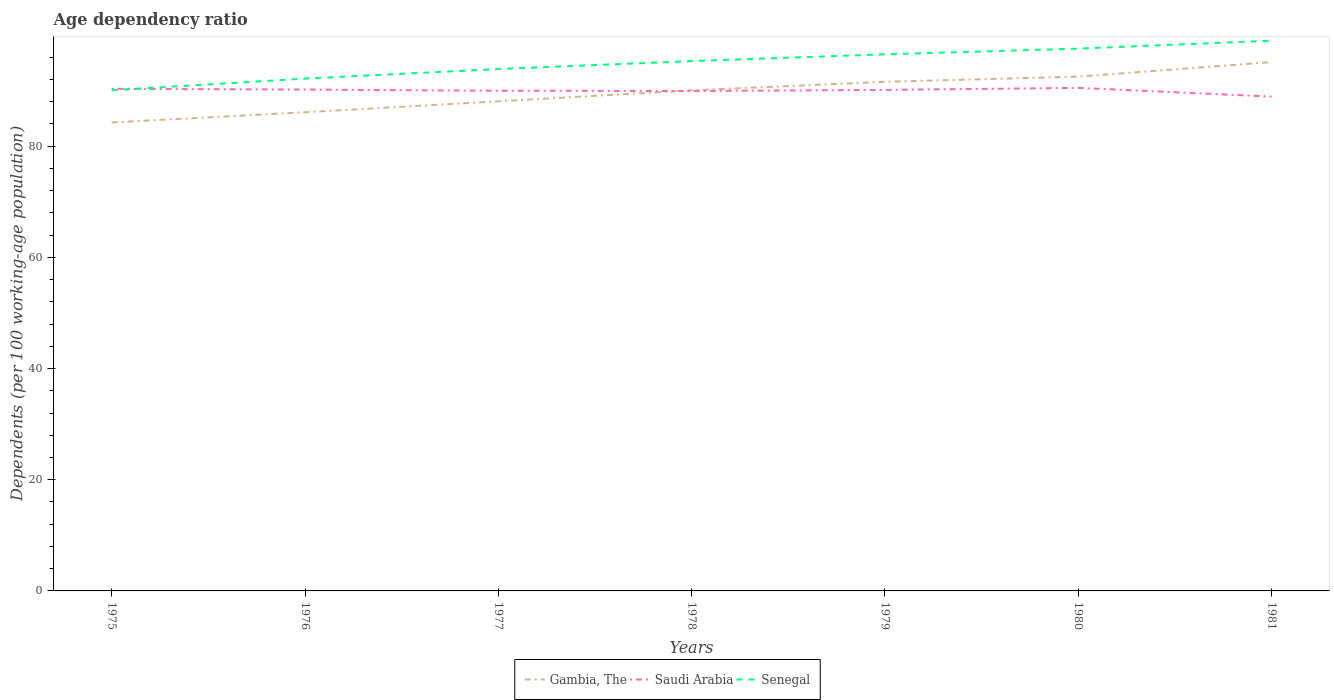Does the line corresponding to Gambia, The intersect with the line corresponding to Senegal?
Make the answer very short. No. Is the number of lines equal to the number of legend labels?
Your response must be concise. Yes. Across all years, what is the maximum age dependency ratio in in Gambia, The?
Ensure brevity in your answer.  84.27. What is the total age dependency ratio in in Saudi Arabia in the graph?
Give a very brief answer. -0.36. What is the difference between the highest and the second highest age dependency ratio in in Senegal?
Provide a short and direct response. 8.92. What is the difference between the highest and the lowest age dependency ratio in in Senegal?
Your answer should be compact. 4. Is the age dependency ratio in in Gambia, The strictly greater than the age dependency ratio in in Saudi Arabia over the years?
Give a very brief answer. No. How many lines are there?
Provide a succinct answer. 3. Are the values on the major ticks of Y-axis written in scientific E-notation?
Ensure brevity in your answer.  No. Does the graph contain any zero values?
Offer a very short reply. No. Where does the legend appear in the graph?
Give a very brief answer. Bottom center. How are the legend labels stacked?
Provide a short and direct response. Horizontal. What is the title of the graph?
Provide a short and direct response. Age dependency ratio. What is the label or title of the X-axis?
Ensure brevity in your answer.  Years. What is the label or title of the Y-axis?
Your answer should be compact. Dependents (per 100 working-age population). What is the Dependents (per 100 working-age population) of Gambia, The in 1975?
Your response must be concise. 84.27. What is the Dependents (per 100 working-age population) of Saudi Arabia in 1975?
Offer a terse response. 90.32. What is the Dependents (per 100 working-age population) of Senegal in 1975?
Make the answer very short. 90.06. What is the Dependents (per 100 working-age population) of Gambia, The in 1976?
Offer a very short reply. 86.1. What is the Dependents (per 100 working-age population) of Saudi Arabia in 1976?
Provide a succinct answer. 90.18. What is the Dependents (per 100 working-age population) of Senegal in 1976?
Provide a succinct answer. 92.16. What is the Dependents (per 100 working-age population) of Gambia, The in 1977?
Provide a short and direct response. 88.07. What is the Dependents (per 100 working-age population) in Saudi Arabia in 1977?
Keep it short and to the point. 89.97. What is the Dependents (per 100 working-age population) in Senegal in 1977?
Provide a succinct answer. 93.88. What is the Dependents (per 100 working-age population) in Gambia, The in 1978?
Provide a short and direct response. 90.04. What is the Dependents (per 100 working-age population) of Saudi Arabia in 1978?
Your response must be concise. 89.92. What is the Dependents (per 100 working-age population) of Senegal in 1978?
Your response must be concise. 95.3. What is the Dependents (per 100 working-age population) in Gambia, The in 1979?
Provide a short and direct response. 91.58. What is the Dependents (per 100 working-age population) in Saudi Arabia in 1979?
Your response must be concise. 90.13. What is the Dependents (per 100 working-age population) of Senegal in 1979?
Keep it short and to the point. 96.52. What is the Dependents (per 100 working-age population) in Gambia, The in 1980?
Keep it short and to the point. 92.51. What is the Dependents (per 100 working-age population) in Saudi Arabia in 1980?
Offer a terse response. 90.49. What is the Dependents (per 100 working-age population) of Senegal in 1980?
Make the answer very short. 97.55. What is the Dependents (per 100 working-age population) in Gambia, The in 1981?
Provide a succinct answer. 95.13. What is the Dependents (per 100 working-age population) of Saudi Arabia in 1981?
Make the answer very short. 88.92. What is the Dependents (per 100 working-age population) of Senegal in 1981?
Ensure brevity in your answer.  98.98. Across all years, what is the maximum Dependents (per 100 working-age population) of Gambia, The?
Make the answer very short. 95.13. Across all years, what is the maximum Dependents (per 100 working-age population) of Saudi Arabia?
Your answer should be very brief. 90.49. Across all years, what is the maximum Dependents (per 100 working-age population) of Senegal?
Offer a very short reply. 98.98. Across all years, what is the minimum Dependents (per 100 working-age population) of Gambia, The?
Provide a short and direct response. 84.27. Across all years, what is the minimum Dependents (per 100 working-age population) of Saudi Arabia?
Your answer should be very brief. 88.92. Across all years, what is the minimum Dependents (per 100 working-age population) in Senegal?
Keep it short and to the point. 90.06. What is the total Dependents (per 100 working-age population) of Gambia, The in the graph?
Give a very brief answer. 627.7. What is the total Dependents (per 100 working-age population) of Saudi Arabia in the graph?
Make the answer very short. 629.92. What is the total Dependents (per 100 working-age population) of Senegal in the graph?
Ensure brevity in your answer.  664.46. What is the difference between the Dependents (per 100 working-age population) in Gambia, The in 1975 and that in 1976?
Keep it short and to the point. -1.83. What is the difference between the Dependents (per 100 working-age population) in Saudi Arabia in 1975 and that in 1976?
Make the answer very short. 0.14. What is the difference between the Dependents (per 100 working-age population) of Senegal in 1975 and that in 1976?
Offer a terse response. -2.1. What is the difference between the Dependents (per 100 working-age population) of Gambia, The in 1975 and that in 1977?
Make the answer very short. -3.8. What is the difference between the Dependents (per 100 working-age population) in Saudi Arabia in 1975 and that in 1977?
Offer a terse response. 0.35. What is the difference between the Dependents (per 100 working-age population) in Senegal in 1975 and that in 1977?
Offer a terse response. -3.81. What is the difference between the Dependents (per 100 working-age population) in Gambia, The in 1975 and that in 1978?
Keep it short and to the point. -5.77. What is the difference between the Dependents (per 100 working-age population) in Saudi Arabia in 1975 and that in 1978?
Provide a short and direct response. 0.4. What is the difference between the Dependents (per 100 working-age population) in Senegal in 1975 and that in 1978?
Provide a short and direct response. -5.24. What is the difference between the Dependents (per 100 working-age population) of Gambia, The in 1975 and that in 1979?
Your answer should be very brief. -7.3. What is the difference between the Dependents (per 100 working-age population) in Saudi Arabia in 1975 and that in 1979?
Keep it short and to the point. 0.19. What is the difference between the Dependents (per 100 working-age population) in Senegal in 1975 and that in 1979?
Offer a terse response. -6.46. What is the difference between the Dependents (per 100 working-age population) of Gambia, The in 1975 and that in 1980?
Ensure brevity in your answer.  -8.23. What is the difference between the Dependents (per 100 working-age population) in Saudi Arabia in 1975 and that in 1980?
Give a very brief answer. -0.17. What is the difference between the Dependents (per 100 working-age population) of Senegal in 1975 and that in 1980?
Your answer should be very brief. -7.49. What is the difference between the Dependents (per 100 working-age population) in Gambia, The in 1975 and that in 1981?
Keep it short and to the point. -10.85. What is the difference between the Dependents (per 100 working-age population) in Saudi Arabia in 1975 and that in 1981?
Give a very brief answer. 1.4. What is the difference between the Dependents (per 100 working-age population) in Senegal in 1975 and that in 1981?
Your answer should be compact. -8.92. What is the difference between the Dependents (per 100 working-age population) in Gambia, The in 1976 and that in 1977?
Make the answer very short. -1.97. What is the difference between the Dependents (per 100 working-age population) of Saudi Arabia in 1976 and that in 1977?
Your answer should be very brief. 0.21. What is the difference between the Dependents (per 100 working-age population) of Senegal in 1976 and that in 1977?
Your answer should be very brief. -1.72. What is the difference between the Dependents (per 100 working-age population) in Gambia, The in 1976 and that in 1978?
Keep it short and to the point. -3.94. What is the difference between the Dependents (per 100 working-age population) in Saudi Arabia in 1976 and that in 1978?
Make the answer very short. 0.26. What is the difference between the Dependents (per 100 working-age population) of Senegal in 1976 and that in 1978?
Offer a very short reply. -3.15. What is the difference between the Dependents (per 100 working-age population) of Gambia, The in 1976 and that in 1979?
Keep it short and to the point. -5.48. What is the difference between the Dependents (per 100 working-age population) of Saudi Arabia in 1976 and that in 1979?
Your answer should be compact. 0.06. What is the difference between the Dependents (per 100 working-age population) of Senegal in 1976 and that in 1979?
Provide a short and direct response. -4.36. What is the difference between the Dependents (per 100 working-age population) in Gambia, The in 1976 and that in 1980?
Offer a terse response. -6.41. What is the difference between the Dependents (per 100 working-age population) in Saudi Arabia in 1976 and that in 1980?
Offer a terse response. -0.31. What is the difference between the Dependents (per 100 working-age population) of Senegal in 1976 and that in 1980?
Offer a very short reply. -5.39. What is the difference between the Dependents (per 100 working-age population) of Gambia, The in 1976 and that in 1981?
Your answer should be compact. -9.03. What is the difference between the Dependents (per 100 working-age population) of Saudi Arabia in 1976 and that in 1981?
Your answer should be very brief. 1.26. What is the difference between the Dependents (per 100 working-age population) of Senegal in 1976 and that in 1981?
Keep it short and to the point. -6.82. What is the difference between the Dependents (per 100 working-age population) in Gambia, The in 1977 and that in 1978?
Make the answer very short. -1.97. What is the difference between the Dependents (per 100 working-age population) in Saudi Arabia in 1977 and that in 1978?
Ensure brevity in your answer.  0.05. What is the difference between the Dependents (per 100 working-age population) of Senegal in 1977 and that in 1978?
Ensure brevity in your answer.  -1.43. What is the difference between the Dependents (per 100 working-age population) of Gambia, The in 1977 and that in 1979?
Provide a succinct answer. -3.51. What is the difference between the Dependents (per 100 working-age population) in Saudi Arabia in 1977 and that in 1979?
Ensure brevity in your answer.  -0.15. What is the difference between the Dependents (per 100 working-age population) of Senegal in 1977 and that in 1979?
Offer a very short reply. -2.65. What is the difference between the Dependents (per 100 working-age population) of Gambia, The in 1977 and that in 1980?
Ensure brevity in your answer.  -4.43. What is the difference between the Dependents (per 100 working-age population) in Saudi Arabia in 1977 and that in 1980?
Give a very brief answer. -0.51. What is the difference between the Dependents (per 100 working-age population) of Senegal in 1977 and that in 1980?
Offer a very short reply. -3.67. What is the difference between the Dependents (per 100 working-age population) in Gambia, The in 1977 and that in 1981?
Ensure brevity in your answer.  -7.05. What is the difference between the Dependents (per 100 working-age population) of Saudi Arabia in 1977 and that in 1981?
Your answer should be compact. 1.05. What is the difference between the Dependents (per 100 working-age population) of Senegal in 1977 and that in 1981?
Make the answer very short. -5.1. What is the difference between the Dependents (per 100 working-age population) in Gambia, The in 1978 and that in 1979?
Make the answer very short. -1.54. What is the difference between the Dependents (per 100 working-age population) in Saudi Arabia in 1978 and that in 1979?
Offer a very short reply. -0.21. What is the difference between the Dependents (per 100 working-age population) of Senegal in 1978 and that in 1979?
Your answer should be very brief. -1.22. What is the difference between the Dependents (per 100 working-age population) in Gambia, The in 1978 and that in 1980?
Keep it short and to the point. -2.47. What is the difference between the Dependents (per 100 working-age population) of Saudi Arabia in 1978 and that in 1980?
Keep it short and to the point. -0.57. What is the difference between the Dependents (per 100 working-age population) in Senegal in 1978 and that in 1980?
Make the answer very short. -2.25. What is the difference between the Dependents (per 100 working-age population) of Gambia, The in 1978 and that in 1981?
Offer a terse response. -5.09. What is the difference between the Dependents (per 100 working-age population) in Saudi Arabia in 1978 and that in 1981?
Your answer should be compact. 1. What is the difference between the Dependents (per 100 working-age population) in Senegal in 1978 and that in 1981?
Offer a very short reply. -3.67. What is the difference between the Dependents (per 100 working-age population) in Gambia, The in 1979 and that in 1980?
Your answer should be very brief. -0.93. What is the difference between the Dependents (per 100 working-age population) in Saudi Arabia in 1979 and that in 1980?
Provide a succinct answer. -0.36. What is the difference between the Dependents (per 100 working-age population) of Senegal in 1979 and that in 1980?
Your answer should be very brief. -1.03. What is the difference between the Dependents (per 100 working-age population) of Gambia, The in 1979 and that in 1981?
Make the answer very short. -3.55. What is the difference between the Dependents (per 100 working-age population) in Saudi Arabia in 1979 and that in 1981?
Offer a very short reply. 1.21. What is the difference between the Dependents (per 100 working-age population) in Senegal in 1979 and that in 1981?
Provide a short and direct response. -2.46. What is the difference between the Dependents (per 100 working-age population) of Gambia, The in 1980 and that in 1981?
Your response must be concise. -2.62. What is the difference between the Dependents (per 100 working-age population) in Saudi Arabia in 1980 and that in 1981?
Offer a terse response. 1.57. What is the difference between the Dependents (per 100 working-age population) of Senegal in 1980 and that in 1981?
Offer a very short reply. -1.43. What is the difference between the Dependents (per 100 working-age population) of Gambia, The in 1975 and the Dependents (per 100 working-age population) of Saudi Arabia in 1976?
Offer a very short reply. -5.91. What is the difference between the Dependents (per 100 working-age population) in Gambia, The in 1975 and the Dependents (per 100 working-age population) in Senegal in 1976?
Give a very brief answer. -7.88. What is the difference between the Dependents (per 100 working-age population) of Saudi Arabia in 1975 and the Dependents (per 100 working-age population) of Senegal in 1976?
Provide a short and direct response. -1.84. What is the difference between the Dependents (per 100 working-age population) of Gambia, The in 1975 and the Dependents (per 100 working-age population) of Saudi Arabia in 1977?
Your response must be concise. -5.7. What is the difference between the Dependents (per 100 working-age population) in Gambia, The in 1975 and the Dependents (per 100 working-age population) in Senegal in 1977?
Offer a terse response. -9.6. What is the difference between the Dependents (per 100 working-age population) of Saudi Arabia in 1975 and the Dependents (per 100 working-age population) of Senegal in 1977?
Your answer should be compact. -3.56. What is the difference between the Dependents (per 100 working-age population) in Gambia, The in 1975 and the Dependents (per 100 working-age population) in Saudi Arabia in 1978?
Provide a short and direct response. -5.64. What is the difference between the Dependents (per 100 working-age population) in Gambia, The in 1975 and the Dependents (per 100 working-age population) in Senegal in 1978?
Provide a succinct answer. -11.03. What is the difference between the Dependents (per 100 working-age population) of Saudi Arabia in 1975 and the Dependents (per 100 working-age population) of Senegal in 1978?
Make the answer very short. -4.99. What is the difference between the Dependents (per 100 working-age population) in Gambia, The in 1975 and the Dependents (per 100 working-age population) in Saudi Arabia in 1979?
Give a very brief answer. -5.85. What is the difference between the Dependents (per 100 working-age population) in Gambia, The in 1975 and the Dependents (per 100 working-age population) in Senegal in 1979?
Give a very brief answer. -12.25. What is the difference between the Dependents (per 100 working-age population) in Saudi Arabia in 1975 and the Dependents (per 100 working-age population) in Senegal in 1979?
Your answer should be very brief. -6.21. What is the difference between the Dependents (per 100 working-age population) of Gambia, The in 1975 and the Dependents (per 100 working-age population) of Saudi Arabia in 1980?
Give a very brief answer. -6.21. What is the difference between the Dependents (per 100 working-age population) of Gambia, The in 1975 and the Dependents (per 100 working-age population) of Senegal in 1980?
Make the answer very short. -13.28. What is the difference between the Dependents (per 100 working-age population) of Saudi Arabia in 1975 and the Dependents (per 100 working-age population) of Senegal in 1980?
Make the answer very short. -7.23. What is the difference between the Dependents (per 100 working-age population) of Gambia, The in 1975 and the Dependents (per 100 working-age population) of Saudi Arabia in 1981?
Ensure brevity in your answer.  -4.64. What is the difference between the Dependents (per 100 working-age population) in Gambia, The in 1975 and the Dependents (per 100 working-age population) in Senegal in 1981?
Offer a very short reply. -14.71. What is the difference between the Dependents (per 100 working-age population) of Saudi Arabia in 1975 and the Dependents (per 100 working-age population) of Senegal in 1981?
Your answer should be compact. -8.66. What is the difference between the Dependents (per 100 working-age population) in Gambia, The in 1976 and the Dependents (per 100 working-age population) in Saudi Arabia in 1977?
Provide a short and direct response. -3.87. What is the difference between the Dependents (per 100 working-age population) of Gambia, The in 1976 and the Dependents (per 100 working-age population) of Senegal in 1977?
Make the answer very short. -7.78. What is the difference between the Dependents (per 100 working-age population) in Saudi Arabia in 1976 and the Dependents (per 100 working-age population) in Senegal in 1977?
Offer a terse response. -3.7. What is the difference between the Dependents (per 100 working-age population) of Gambia, The in 1976 and the Dependents (per 100 working-age population) of Saudi Arabia in 1978?
Make the answer very short. -3.82. What is the difference between the Dependents (per 100 working-age population) in Gambia, The in 1976 and the Dependents (per 100 working-age population) in Senegal in 1978?
Your answer should be compact. -9.21. What is the difference between the Dependents (per 100 working-age population) in Saudi Arabia in 1976 and the Dependents (per 100 working-age population) in Senegal in 1978?
Your response must be concise. -5.12. What is the difference between the Dependents (per 100 working-age population) of Gambia, The in 1976 and the Dependents (per 100 working-age population) of Saudi Arabia in 1979?
Give a very brief answer. -4.03. What is the difference between the Dependents (per 100 working-age population) in Gambia, The in 1976 and the Dependents (per 100 working-age population) in Senegal in 1979?
Ensure brevity in your answer.  -10.42. What is the difference between the Dependents (per 100 working-age population) of Saudi Arabia in 1976 and the Dependents (per 100 working-age population) of Senegal in 1979?
Provide a succinct answer. -6.34. What is the difference between the Dependents (per 100 working-age population) in Gambia, The in 1976 and the Dependents (per 100 working-age population) in Saudi Arabia in 1980?
Your response must be concise. -4.39. What is the difference between the Dependents (per 100 working-age population) in Gambia, The in 1976 and the Dependents (per 100 working-age population) in Senegal in 1980?
Offer a very short reply. -11.45. What is the difference between the Dependents (per 100 working-age population) of Saudi Arabia in 1976 and the Dependents (per 100 working-age population) of Senegal in 1980?
Give a very brief answer. -7.37. What is the difference between the Dependents (per 100 working-age population) of Gambia, The in 1976 and the Dependents (per 100 working-age population) of Saudi Arabia in 1981?
Keep it short and to the point. -2.82. What is the difference between the Dependents (per 100 working-age population) of Gambia, The in 1976 and the Dependents (per 100 working-age population) of Senegal in 1981?
Ensure brevity in your answer.  -12.88. What is the difference between the Dependents (per 100 working-age population) of Saudi Arabia in 1976 and the Dependents (per 100 working-age population) of Senegal in 1981?
Give a very brief answer. -8.8. What is the difference between the Dependents (per 100 working-age population) in Gambia, The in 1977 and the Dependents (per 100 working-age population) in Saudi Arabia in 1978?
Your response must be concise. -1.85. What is the difference between the Dependents (per 100 working-age population) in Gambia, The in 1977 and the Dependents (per 100 working-age population) in Senegal in 1978?
Your answer should be very brief. -7.23. What is the difference between the Dependents (per 100 working-age population) of Saudi Arabia in 1977 and the Dependents (per 100 working-age population) of Senegal in 1978?
Provide a succinct answer. -5.33. What is the difference between the Dependents (per 100 working-age population) in Gambia, The in 1977 and the Dependents (per 100 working-age population) in Saudi Arabia in 1979?
Your response must be concise. -2.05. What is the difference between the Dependents (per 100 working-age population) of Gambia, The in 1977 and the Dependents (per 100 working-age population) of Senegal in 1979?
Provide a short and direct response. -8.45. What is the difference between the Dependents (per 100 working-age population) in Saudi Arabia in 1977 and the Dependents (per 100 working-age population) in Senegal in 1979?
Make the answer very short. -6.55. What is the difference between the Dependents (per 100 working-age population) in Gambia, The in 1977 and the Dependents (per 100 working-age population) in Saudi Arabia in 1980?
Provide a succinct answer. -2.41. What is the difference between the Dependents (per 100 working-age population) in Gambia, The in 1977 and the Dependents (per 100 working-age population) in Senegal in 1980?
Ensure brevity in your answer.  -9.48. What is the difference between the Dependents (per 100 working-age population) of Saudi Arabia in 1977 and the Dependents (per 100 working-age population) of Senegal in 1980?
Ensure brevity in your answer.  -7.58. What is the difference between the Dependents (per 100 working-age population) in Gambia, The in 1977 and the Dependents (per 100 working-age population) in Saudi Arabia in 1981?
Make the answer very short. -0.84. What is the difference between the Dependents (per 100 working-age population) of Gambia, The in 1977 and the Dependents (per 100 working-age population) of Senegal in 1981?
Your answer should be very brief. -10.91. What is the difference between the Dependents (per 100 working-age population) of Saudi Arabia in 1977 and the Dependents (per 100 working-age population) of Senegal in 1981?
Offer a terse response. -9.01. What is the difference between the Dependents (per 100 working-age population) in Gambia, The in 1978 and the Dependents (per 100 working-age population) in Saudi Arabia in 1979?
Provide a succinct answer. -0.08. What is the difference between the Dependents (per 100 working-age population) in Gambia, The in 1978 and the Dependents (per 100 working-age population) in Senegal in 1979?
Make the answer very short. -6.48. What is the difference between the Dependents (per 100 working-age population) of Saudi Arabia in 1978 and the Dependents (per 100 working-age population) of Senegal in 1979?
Keep it short and to the point. -6.6. What is the difference between the Dependents (per 100 working-age population) in Gambia, The in 1978 and the Dependents (per 100 working-age population) in Saudi Arabia in 1980?
Offer a very short reply. -0.45. What is the difference between the Dependents (per 100 working-age population) of Gambia, The in 1978 and the Dependents (per 100 working-age population) of Senegal in 1980?
Your answer should be very brief. -7.51. What is the difference between the Dependents (per 100 working-age population) in Saudi Arabia in 1978 and the Dependents (per 100 working-age population) in Senegal in 1980?
Keep it short and to the point. -7.63. What is the difference between the Dependents (per 100 working-age population) of Gambia, The in 1978 and the Dependents (per 100 working-age population) of Saudi Arabia in 1981?
Your response must be concise. 1.12. What is the difference between the Dependents (per 100 working-age population) of Gambia, The in 1978 and the Dependents (per 100 working-age population) of Senegal in 1981?
Your answer should be compact. -8.94. What is the difference between the Dependents (per 100 working-age population) of Saudi Arabia in 1978 and the Dependents (per 100 working-age population) of Senegal in 1981?
Offer a terse response. -9.06. What is the difference between the Dependents (per 100 working-age population) in Gambia, The in 1979 and the Dependents (per 100 working-age population) in Saudi Arabia in 1980?
Keep it short and to the point. 1.09. What is the difference between the Dependents (per 100 working-age population) of Gambia, The in 1979 and the Dependents (per 100 working-age population) of Senegal in 1980?
Your answer should be compact. -5.97. What is the difference between the Dependents (per 100 working-age population) of Saudi Arabia in 1979 and the Dependents (per 100 working-age population) of Senegal in 1980?
Make the answer very short. -7.42. What is the difference between the Dependents (per 100 working-age population) in Gambia, The in 1979 and the Dependents (per 100 working-age population) in Saudi Arabia in 1981?
Give a very brief answer. 2.66. What is the difference between the Dependents (per 100 working-age population) of Gambia, The in 1979 and the Dependents (per 100 working-age population) of Senegal in 1981?
Ensure brevity in your answer.  -7.4. What is the difference between the Dependents (per 100 working-age population) of Saudi Arabia in 1979 and the Dependents (per 100 working-age population) of Senegal in 1981?
Provide a succinct answer. -8.85. What is the difference between the Dependents (per 100 working-age population) of Gambia, The in 1980 and the Dependents (per 100 working-age population) of Saudi Arabia in 1981?
Your answer should be very brief. 3.59. What is the difference between the Dependents (per 100 working-age population) of Gambia, The in 1980 and the Dependents (per 100 working-age population) of Senegal in 1981?
Your response must be concise. -6.47. What is the difference between the Dependents (per 100 working-age population) of Saudi Arabia in 1980 and the Dependents (per 100 working-age population) of Senegal in 1981?
Ensure brevity in your answer.  -8.49. What is the average Dependents (per 100 working-age population) of Gambia, The per year?
Provide a succinct answer. 89.67. What is the average Dependents (per 100 working-age population) of Saudi Arabia per year?
Offer a very short reply. 89.99. What is the average Dependents (per 100 working-age population) of Senegal per year?
Give a very brief answer. 94.92. In the year 1975, what is the difference between the Dependents (per 100 working-age population) of Gambia, The and Dependents (per 100 working-age population) of Saudi Arabia?
Offer a terse response. -6.04. In the year 1975, what is the difference between the Dependents (per 100 working-age population) in Gambia, The and Dependents (per 100 working-age population) in Senegal?
Offer a very short reply. -5.79. In the year 1975, what is the difference between the Dependents (per 100 working-age population) of Saudi Arabia and Dependents (per 100 working-age population) of Senegal?
Provide a short and direct response. 0.25. In the year 1976, what is the difference between the Dependents (per 100 working-age population) in Gambia, The and Dependents (per 100 working-age population) in Saudi Arabia?
Provide a short and direct response. -4.08. In the year 1976, what is the difference between the Dependents (per 100 working-age population) in Gambia, The and Dependents (per 100 working-age population) in Senegal?
Make the answer very short. -6.06. In the year 1976, what is the difference between the Dependents (per 100 working-age population) in Saudi Arabia and Dependents (per 100 working-age population) in Senegal?
Your answer should be very brief. -1.98. In the year 1977, what is the difference between the Dependents (per 100 working-age population) of Gambia, The and Dependents (per 100 working-age population) of Saudi Arabia?
Provide a short and direct response. -1.9. In the year 1977, what is the difference between the Dependents (per 100 working-age population) of Gambia, The and Dependents (per 100 working-age population) of Senegal?
Provide a short and direct response. -5.8. In the year 1977, what is the difference between the Dependents (per 100 working-age population) in Saudi Arabia and Dependents (per 100 working-age population) in Senegal?
Give a very brief answer. -3.9. In the year 1978, what is the difference between the Dependents (per 100 working-age population) in Gambia, The and Dependents (per 100 working-age population) in Saudi Arabia?
Make the answer very short. 0.12. In the year 1978, what is the difference between the Dependents (per 100 working-age population) in Gambia, The and Dependents (per 100 working-age population) in Senegal?
Your answer should be very brief. -5.26. In the year 1978, what is the difference between the Dependents (per 100 working-age population) of Saudi Arabia and Dependents (per 100 working-age population) of Senegal?
Give a very brief answer. -5.39. In the year 1979, what is the difference between the Dependents (per 100 working-age population) in Gambia, The and Dependents (per 100 working-age population) in Saudi Arabia?
Keep it short and to the point. 1.45. In the year 1979, what is the difference between the Dependents (per 100 working-age population) in Gambia, The and Dependents (per 100 working-age population) in Senegal?
Make the answer very short. -4.94. In the year 1979, what is the difference between the Dependents (per 100 working-age population) in Saudi Arabia and Dependents (per 100 working-age population) in Senegal?
Give a very brief answer. -6.4. In the year 1980, what is the difference between the Dependents (per 100 working-age population) in Gambia, The and Dependents (per 100 working-age population) in Saudi Arabia?
Give a very brief answer. 2.02. In the year 1980, what is the difference between the Dependents (per 100 working-age population) of Gambia, The and Dependents (per 100 working-age population) of Senegal?
Give a very brief answer. -5.04. In the year 1980, what is the difference between the Dependents (per 100 working-age population) in Saudi Arabia and Dependents (per 100 working-age population) in Senegal?
Your answer should be compact. -7.06. In the year 1981, what is the difference between the Dependents (per 100 working-age population) of Gambia, The and Dependents (per 100 working-age population) of Saudi Arabia?
Provide a succinct answer. 6.21. In the year 1981, what is the difference between the Dependents (per 100 working-age population) in Gambia, The and Dependents (per 100 working-age population) in Senegal?
Provide a short and direct response. -3.85. In the year 1981, what is the difference between the Dependents (per 100 working-age population) of Saudi Arabia and Dependents (per 100 working-age population) of Senegal?
Your answer should be compact. -10.06. What is the ratio of the Dependents (per 100 working-age population) in Gambia, The in 1975 to that in 1976?
Provide a short and direct response. 0.98. What is the ratio of the Dependents (per 100 working-age population) of Saudi Arabia in 1975 to that in 1976?
Your response must be concise. 1. What is the ratio of the Dependents (per 100 working-age population) in Senegal in 1975 to that in 1976?
Your response must be concise. 0.98. What is the ratio of the Dependents (per 100 working-age population) of Gambia, The in 1975 to that in 1977?
Provide a short and direct response. 0.96. What is the ratio of the Dependents (per 100 working-age population) in Saudi Arabia in 1975 to that in 1977?
Offer a very short reply. 1. What is the ratio of the Dependents (per 100 working-age population) in Senegal in 1975 to that in 1977?
Your answer should be compact. 0.96. What is the ratio of the Dependents (per 100 working-age population) of Gambia, The in 1975 to that in 1978?
Offer a terse response. 0.94. What is the ratio of the Dependents (per 100 working-age population) of Senegal in 1975 to that in 1978?
Provide a succinct answer. 0.94. What is the ratio of the Dependents (per 100 working-age population) of Gambia, The in 1975 to that in 1979?
Provide a succinct answer. 0.92. What is the ratio of the Dependents (per 100 working-age population) in Saudi Arabia in 1975 to that in 1979?
Make the answer very short. 1. What is the ratio of the Dependents (per 100 working-age population) of Senegal in 1975 to that in 1979?
Give a very brief answer. 0.93. What is the ratio of the Dependents (per 100 working-age population) of Gambia, The in 1975 to that in 1980?
Offer a terse response. 0.91. What is the ratio of the Dependents (per 100 working-age population) of Saudi Arabia in 1975 to that in 1980?
Ensure brevity in your answer.  1. What is the ratio of the Dependents (per 100 working-age population) in Senegal in 1975 to that in 1980?
Make the answer very short. 0.92. What is the ratio of the Dependents (per 100 working-age population) in Gambia, The in 1975 to that in 1981?
Your answer should be very brief. 0.89. What is the ratio of the Dependents (per 100 working-age population) of Saudi Arabia in 1975 to that in 1981?
Provide a short and direct response. 1.02. What is the ratio of the Dependents (per 100 working-age population) of Senegal in 1975 to that in 1981?
Keep it short and to the point. 0.91. What is the ratio of the Dependents (per 100 working-age population) in Gambia, The in 1976 to that in 1977?
Make the answer very short. 0.98. What is the ratio of the Dependents (per 100 working-age population) in Saudi Arabia in 1976 to that in 1977?
Keep it short and to the point. 1. What is the ratio of the Dependents (per 100 working-age population) in Senegal in 1976 to that in 1977?
Your answer should be very brief. 0.98. What is the ratio of the Dependents (per 100 working-age population) of Gambia, The in 1976 to that in 1978?
Offer a very short reply. 0.96. What is the ratio of the Dependents (per 100 working-age population) in Gambia, The in 1976 to that in 1979?
Your answer should be very brief. 0.94. What is the ratio of the Dependents (per 100 working-age population) in Senegal in 1976 to that in 1979?
Your answer should be very brief. 0.95. What is the ratio of the Dependents (per 100 working-age population) of Gambia, The in 1976 to that in 1980?
Offer a very short reply. 0.93. What is the ratio of the Dependents (per 100 working-age population) of Senegal in 1976 to that in 1980?
Ensure brevity in your answer.  0.94. What is the ratio of the Dependents (per 100 working-age population) of Gambia, The in 1976 to that in 1981?
Your answer should be very brief. 0.91. What is the ratio of the Dependents (per 100 working-age population) of Saudi Arabia in 1976 to that in 1981?
Provide a succinct answer. 1.01. What is the ratio of the Dependents (per 100 working-age population) in Senegal in 1976 to that in 1981?
Provide a succinct answer. 0.93. What is the ratio of the Dependents (per 100 working-age population) of Gambia, The in 1977 to that in 1978?
Make the answer very short. 0.98. What is the ratio of the Dependents (per 100 working-age population) of Saudi Arabia in 1977 to that in 1978?
Offer a terse response. 1. What is the ratio of the Dependents (per 100 working-age population) of Gambia, The in 1977 to that in 1979?
Provide a succinct answer. 0.96. What is the ratio of the Dependents (per 100 working-age population) in Senegal in 1977 to that in 1979?
Keep it short and to the point. 0.97. What is the ratio of the Dependents (per 100 working-age population) in Gambia, The in 1977 to that in 1980?
Provide a short and direct response. 0.95. What is the ratio of the Dependents (per 100 working-age population) in Senegal in 1977 to that in 1980?
Ensure brevity in your answer.  0.96. What is the ratio of the Dependents (per 100 working-age population) in Gambia, The in 1977 to that in 1981?
Provide a short and direct response. 0.93. What is the ratio of the Dependents (per 100 working-age population) in Saudi Arabia in 1977 to that in 1981?
Your answer should be compact. 1.01. What is the ratio of the Dependents (per 100 working-age population) in Senegal in 1977 to that in 1981?
Make the answer very short. 0.95. What is the ratio of the Dependents (per 100 working-age population) in Gambia, The in 1978 to that in 1979?
Your response must be concise. 0.98. What is the ratio of the Dependents (per 100 working-age population) of Senegal in 1978 to that in 1979?
Give a very brief answer. 0.99. What is the ratio of the Dependents (per 100 working-age population) of Gambia, The in 1978 to that in 1980?
Offer a very short reply. 0.97. What is the ratio of the Dependents (per 100 working-age population) in Senegal in 1978 to that in 1980?
Your answer should be very brief. 0.98. What is the ratio of the Dependents (per 100 working-age population) in Gambia, The in 1978 to that in 1981?
Your answer should be compact. 0.95. What is the ratio of the Dependents (per 100 working-age population) of Saudi Arabia in 1978 to that in 1981?
Offer a very short reply. 1.01. What is the ratio of the Dependents (per 100 working-age population) in Senegal in 1978 to that in 1981?
Keep it short and to the point. 0.96. What is the ratio of the Dependents (per 100 working-age population) in Senegal in 1979 to that in 1980?
Provide a succinct answer. 0.99. What is the ratio of the Dependents (per 100 working-age population) of Gambia, The in 1979 to that in 1981?
Your answer should be compact. 0.96. What is the ratio of the Dependents (per 100 working-age population) of Saudi Arabia in 1979 to that in 1981?
Ensure brevity in your answer.  1.01. What is the ratio of the Dependents (per 100 working-age population) of Senegal in 1979 to that in 1981?
Your answer should be very brief. 0.98. What is the ratio of the Dependents (per 100 working-age population) in Gambia, The in 1980 to that in 1981?
Your answer should be very brief. 0.97. What is the ratio of the Dependents (per 100 working-age population) of Saudi Arabia in 1980 to that in 1981?
Your answer should be very brief. 1.02. What is the ratio of the Dependents (per 100 working-age population) of Senegal in 1980 to that in 1981?
Provide a short and direct response. 0.99. What is the difference between the highest and the second highest Dependents (per 100 working-age population) in Gambia, The?
Offer a very short reply. 2.62. What is the difference between the highest and the second highest Dependents (per 100 working-age population) of Saudi Arabia?
Provide a short and direct response. 0.17. What is the difference between the highest and the second highest Dependents (per 100 working-age population) of Senegal?
Give a very brief answer. 1.43. What is the difference between the highest and the lowest Dependents (per 100 working-age population) of Gambia, The?
Make the answer very short. 10.85. What is the difference between the highest and the lowest Dependents (per 100 working-age population) in Saudi Arabia?
Offer a terse response. 1.57. What is the difference between the highest and the lowest Dependents (per 100 working-age population) in Senegal?
Provide a short and direct response. 8.92. 